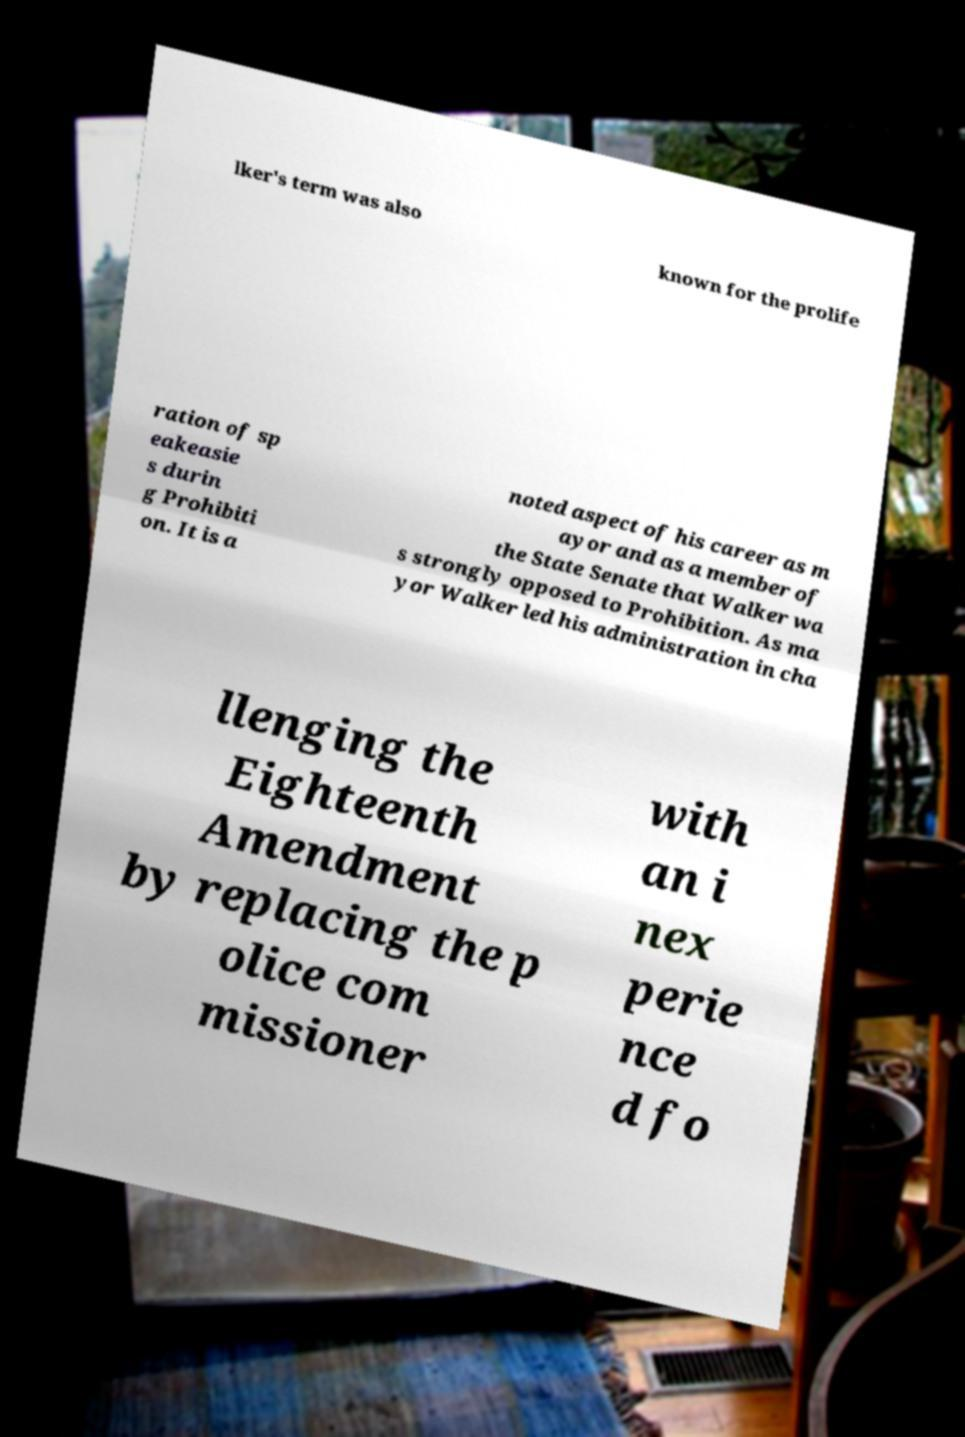For documentation purposes, I need the text within this image transcribed. Could you provide that? lker's term was also known for the prolife ration of sp eakeasie s durin g Prohibiti on. It is a noted aspect of his career as m ayor and as a member of the State Senate that Walker wa s strongly opposed to Prohibition. As ma yor Walker led his administration in cha llenging the Eighteenth Amendment by replacing the p olice com missioner with an i nex perie nce d fo 